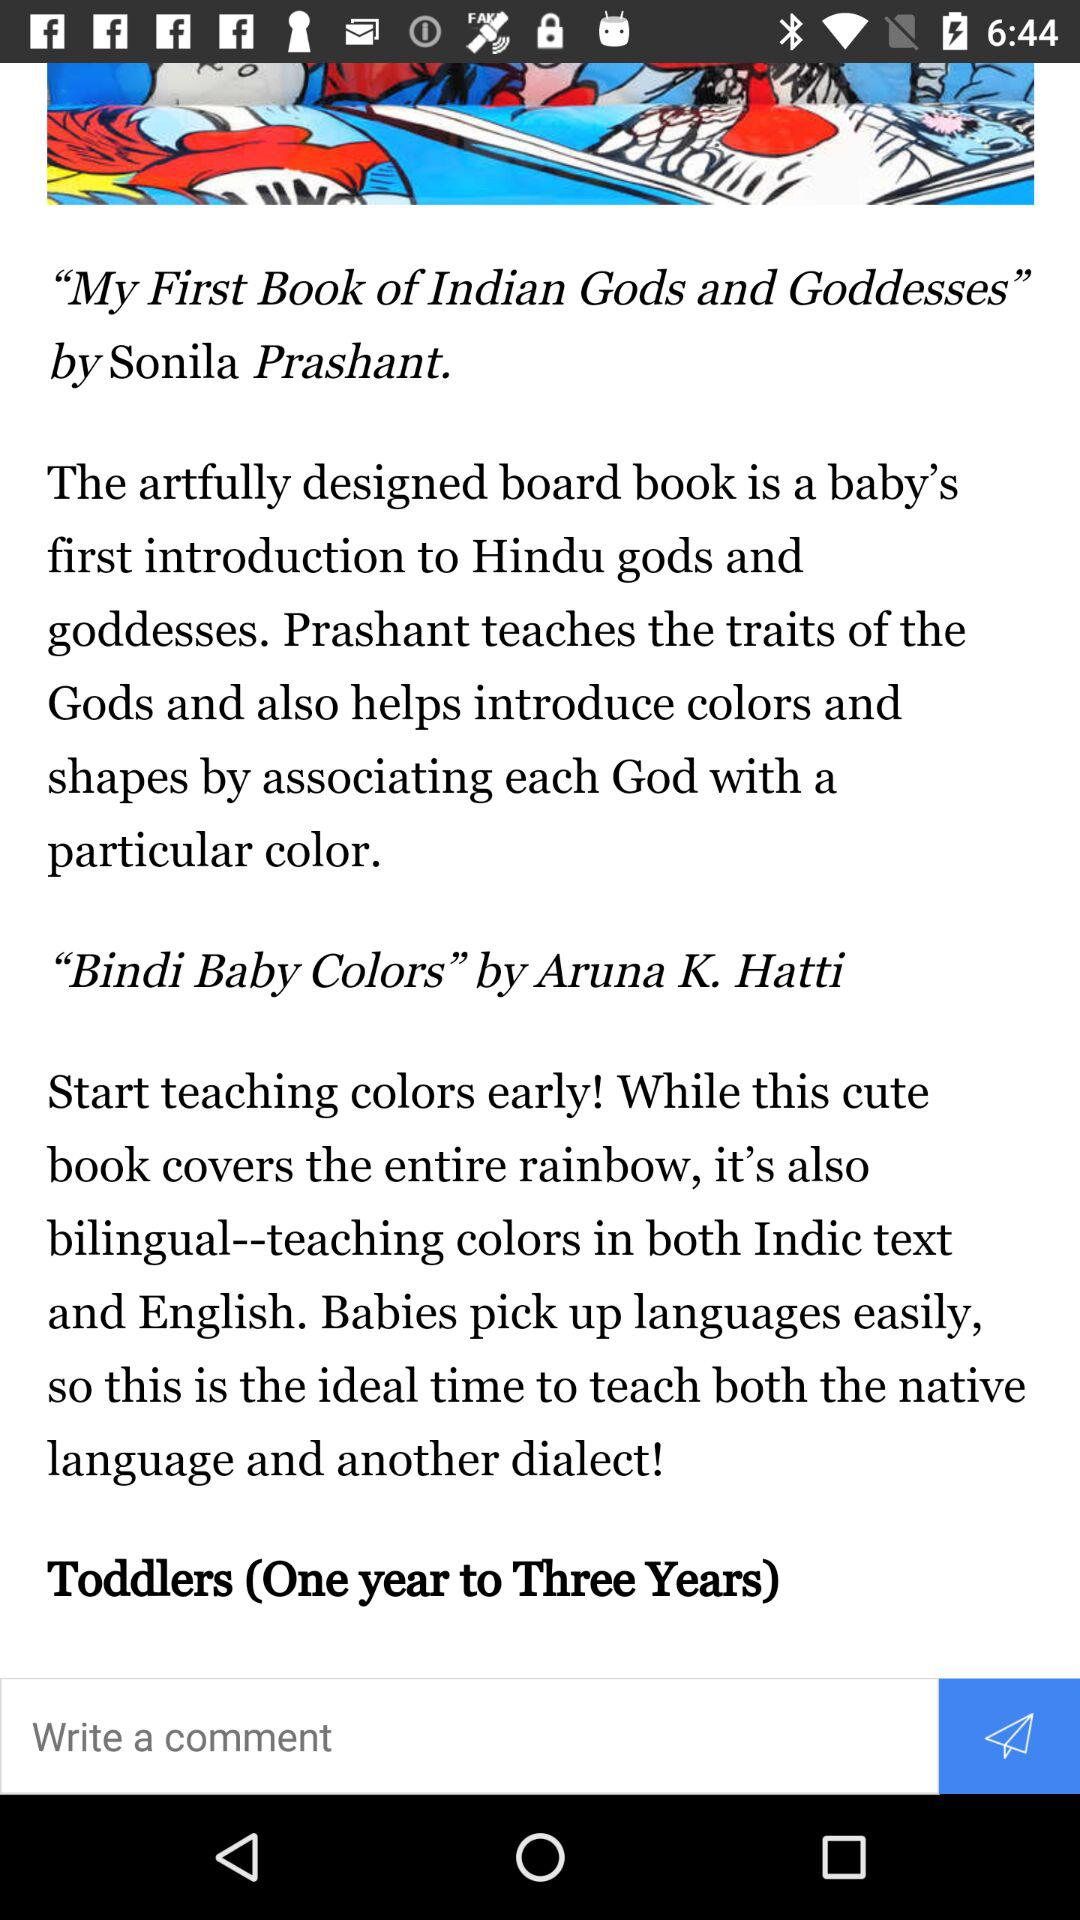What is the specified age range for toddlers? The specified age range is one year to three years. 